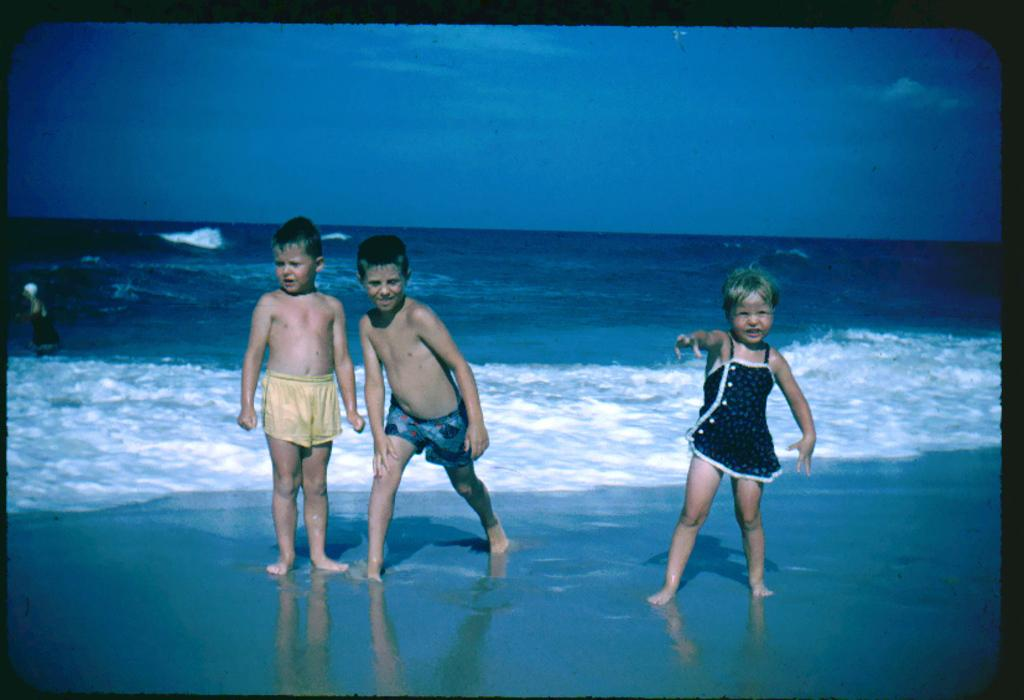Who is present in the image? There are children in the image. Where are the children located? The children are on the sea shore. What can be seen in the background of the image? The sky is visible in the background of the image. What type of boundary can be seen in the image? There is no boundary present in the image; it features children on the sea shore with the sky visible in the background. 